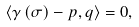<formula> <loc_0><loc_0><loc_500><loc_500>\langle \gamma \left ( \sigma \right ) - p , q \rangle = 0 ,</formula> 